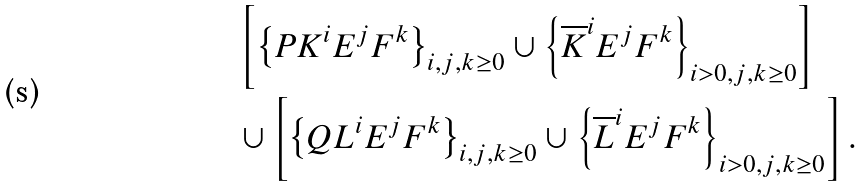<formula> <loc_0><loc_0><loc_500><loc_500>& \left [ \left \{ P K ^ { i } E ^ { j } F ^ { k } \right \} _ { i , j , k \geq 0 } \cup \left \{ \overline { K } ^ { i } E ^ { j } F ^ { k } \right \} _ { i > 0 , j , k \geq 0 } \right ] \\ & \cup \left [ \left \{ Q L ^ { i } E ^ { j } F ^ { k } \right \} _ { i , j , k \geq 0 } \cup \left \{ \overline { L } ^ { i } E ^ { j } F ^ { k } \right \} _ { i > 0 , j , k \geq 0 } \right ] .</formula> 